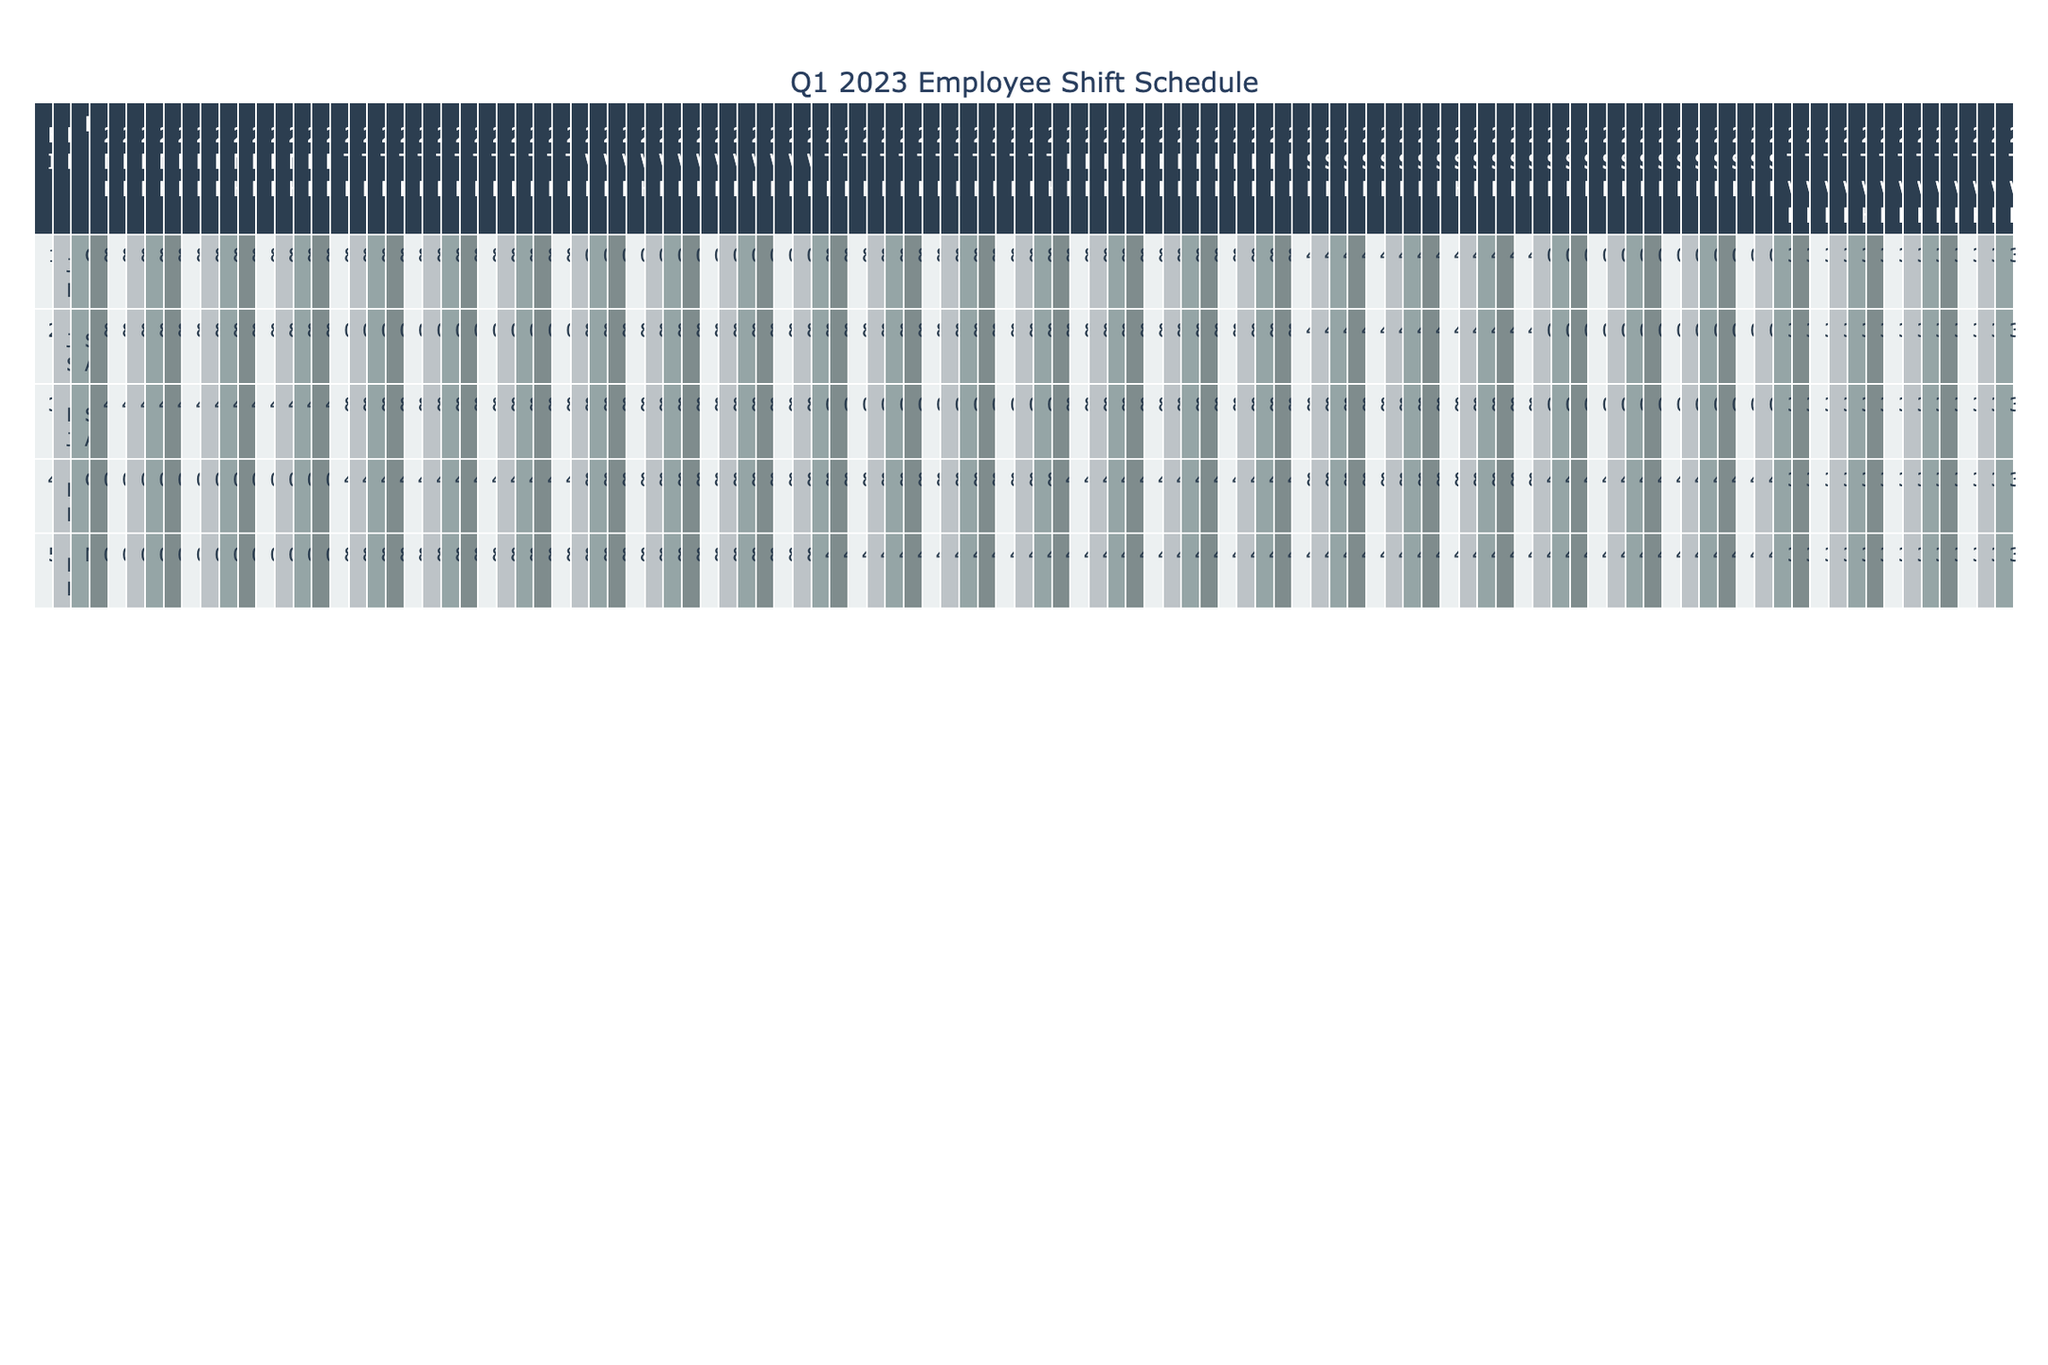What is the maximum number of hours worked by an individual employee in a week? The table shows that the highest number of total weekly hours for any employee in a week is 36 hours. This can be seen across multiple weeks for various employees.
Answer: 36 Who worked the least number of hours on Wednesday for the week starting January 2, 2023? The hours worked on Wednesday for the week starting January 2 are: John Doe (0), Jane Smith (8), Bob Johnson (8), Emily Davis (8), Michael Brown (8). John Doe worked the least with 0 hours.
Answer: John Doe How many shifts did Michael Brown work on Saturdays throughout Q1 2023? Reviewing the data, Michael Brown worked on Saturdays for the weeks of January 2, 9, 16, 23, 30, February 6, 13, 20, 27, March 6, 13, 20, 27, which totals to 13 Saturdays, indicating an accountable pattern of consistent coverage.
Answer: 13 What is the average total weekly hours worked by all employees across Q1 2023? First, note that each employee consistently works 36 hours per week except for Michael Brown, who works 32 hours. With 12 instances of 36 and 4 instances of 32, the calculation would be: ((12 * 36) + (4 * 32)) / 16 = (432 + 128) / 16 = 560 / 16 = 35 hours on average.
Answer: 35 Did any employee work the same total weekly hours every week? By examining each employee's total weekly hours, we find that John Doe, Jane Smith, Bob Johnson, and Emily Davis each consistently worked 36 hours every week during the observed period.
Answer: Yes Which position had the most variation in hours worked across the weeks? Looking at the data, the Stock Associate position (held by Jane Smith) had consistent hours worked (36 hours every week), while Cashiers varied less. Therefore, there is no significant variation across these recorded weeks for this role.
Answer: Stock Associate How many hours did Emily Davis work in total for the Sundays of Q1 2023? For Sundays, the hours logged by Emily Davis are 4 for each of the 13 weeks in Q1. The total calculation is 4 hours * 13 weeks = 52 hours over the quarter.
Answer: 52 Which employee had the highest concentration of hours worked on the weekends? Reviewing Saturday and Sunday hours, Bob Johnson worked 8 hours each Saturday for 13 weeks and did not work Sundays, while Emily Davis matches this on Saturday as well with varied Sunday hours. Thus, Bob's total weekend hours are significant compared to others who rotated less consistently in coverage.
Answer: Bob Johnson What was the shift pattern for John Doe throughout February? John Doe worked consistent 8-hour shifts on Mondays and Tuesdays, with varied hours across the rest of the week, maintaining 36 hours weekly, hence exhibiting a stable shift pattern throughout February.
Answer: Consistent 36 hours Did any of the employees work every single day in a week? Referring to the hours worked across each day in the schedule, every employee had at least one day with 0 hours, which indicates nobody worked every day in a week.
Answer: No 